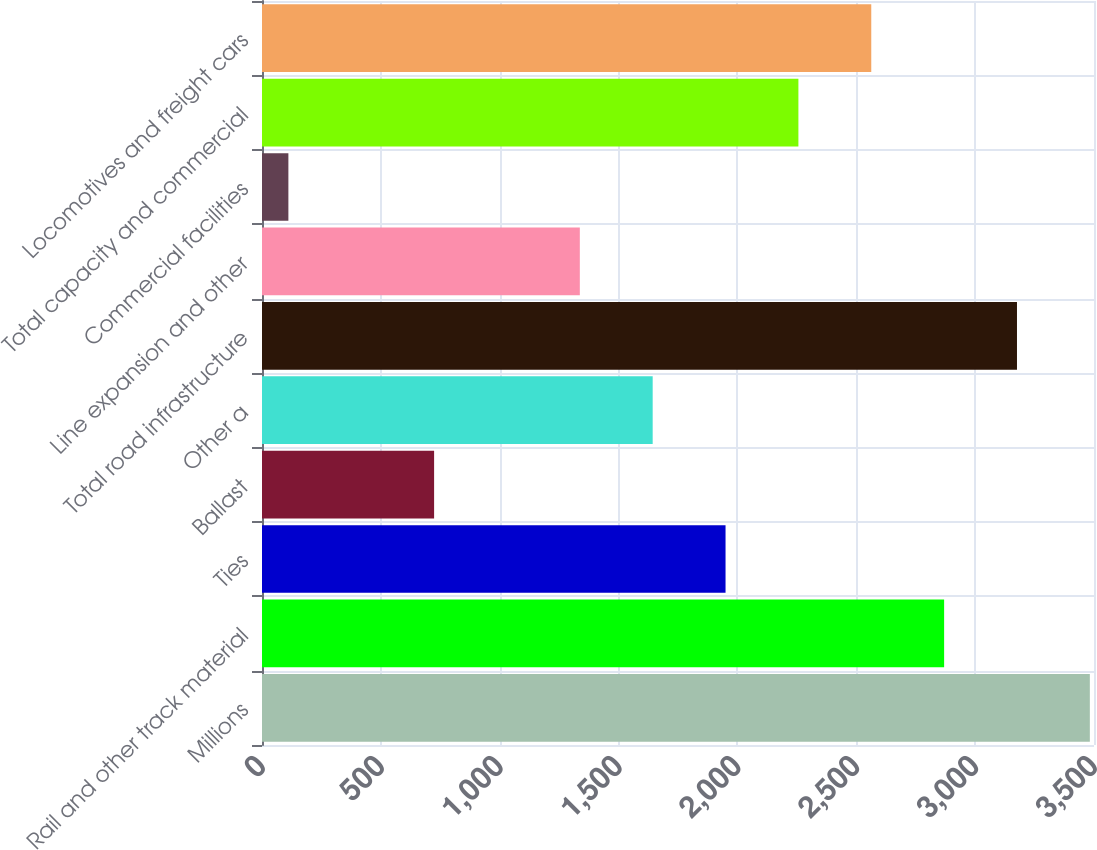Convert chart to OTSL. <chart><loc_0><loc_0><loc_500><loc_500><bar_chart><fcel>Millions<fcel>Rail and other track material<fcel>Ties<fcel>Ballast<fcel>Other a<fcel>Total road infrastructure<fcel>Line expansion and other<fcel>Commercial facilities<fcel>Total capacity and commercial<fcel>Locomotives and freight cars<nl><fcel>3482.5<fcel>2869.5<fcel>1950<fcel>724<fcel>1643.5<fcel>3176<fcel>1337<fcel>111<fcel>2256.5<fcel>2563<nl></chart> 